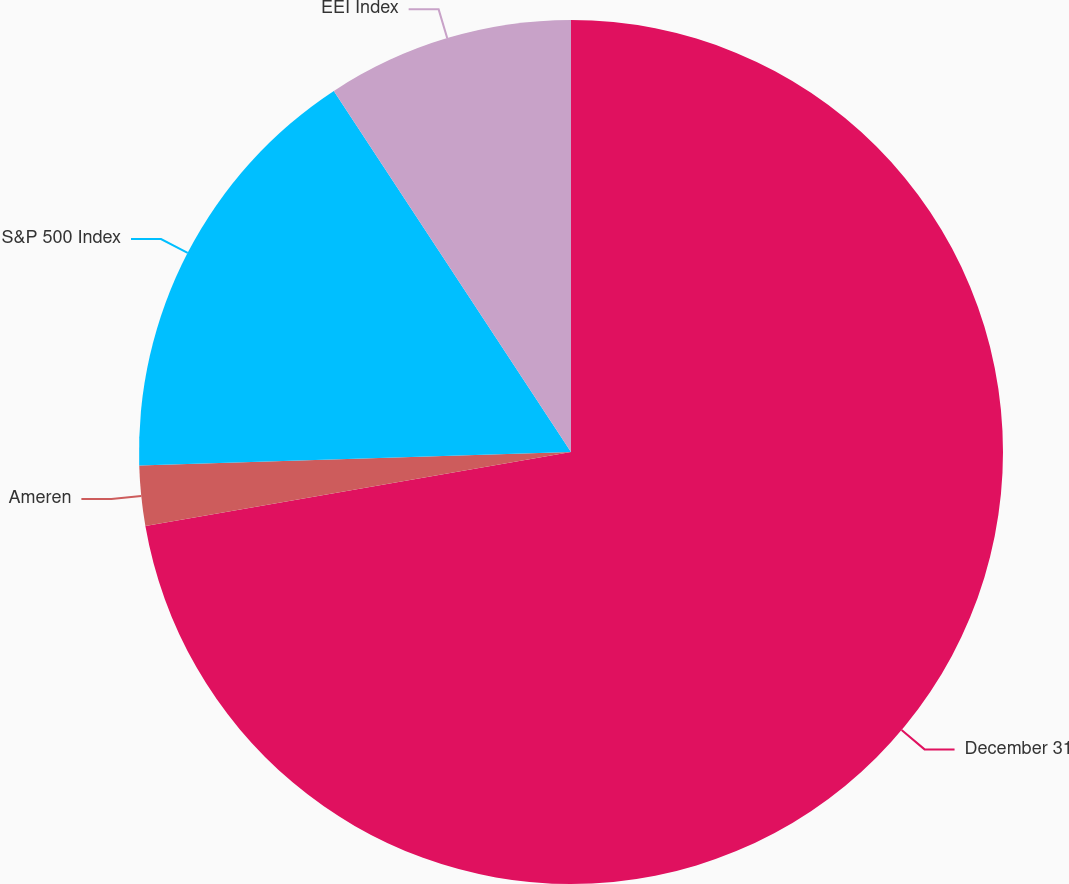Convert chart to OTSL. <chart><loc_0><loc_0><loc_500><loc_500><pie_chart><fcel>December 31<fcel>Ameren<fcel>S&P 500 Index<fcel>EEI Index<nl><fcel>72.26%<fcel>2.24%<fcel>16.25%<fcel>9.25%<nl></chart> 